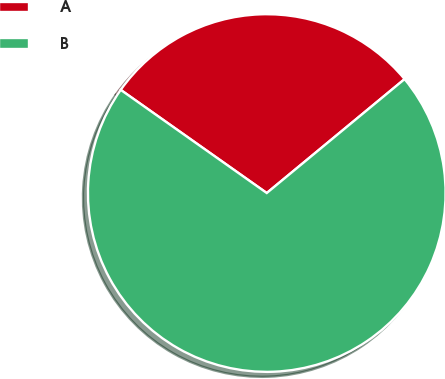Convert chart to OTSL. <chart><loc_0><loc_0><loc_500><loc_500><pie_chart><fcel>A<fcel>B<nl><fcel>29.22%<fcel>70.78%<nl></chart> 